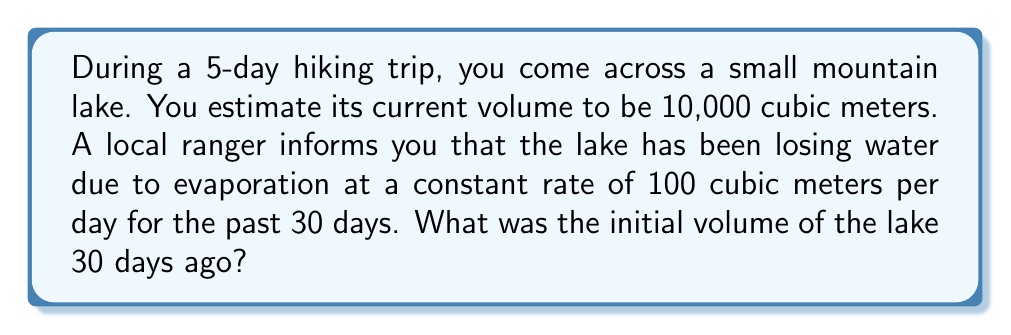Provide a solution to this math problem. Let's approach this step-by-step:

1) First, let's define our variables:
   $V_f$ = final volume (current volume) = 10,000 m³
   $r$ = evaporation rate = 100 m³/day
   $t$ = time period = 30 days
   $V_i$ = initial volume (what we're solving for)

2) We know that the initial volume minus the total water lost due to evaporation equals the final volume:

   $V_i - (r \times t) = V_f$

3) Rearranging this equation to solve for $V_i$:

   $V_i = V_f + (r \times t)$

4) Now, let's substitute our known values:

   $V_i = 10,000 + (100 \times 30)$

5) Simplify:

   $V_i = 10,000 + 3,000 = 13,000$

Therefore, the initial volume of the lake 30 days ago was 13,000 cubic meters.
Answer: 13,000 m³ 